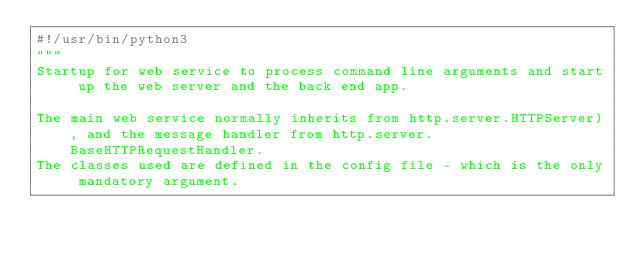Convert code to text. <code><loc_0><loc_0><loc_500><loc_500><_Python_>#!/usr/bin/python3
"""
Startup for web service to process command line arguments and start up the web server and the back end app.

The main web service normally inherits from http.server.HTTPServer), and the message handler from http.server.BaseHTTPRequestHandler.
The classes used are defined in the config file - which is the only mandatory argument.
</code> 